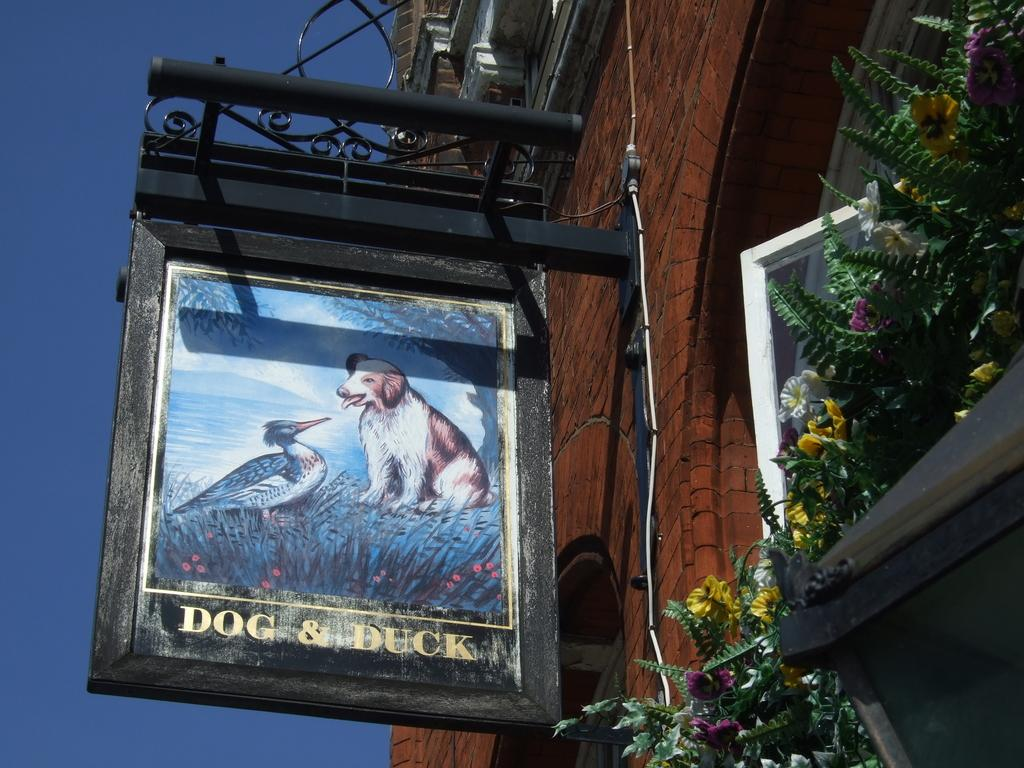What object is attached to the building through metal rods in the image? There is a photo frame in the image that is attached to the building through metal rods. What type of windows does the building have? The building has glass windows. What can be seen on the glass windows? Flowers and plants are present on the glass windows. What else is visible in the image? There are cables visible in the image. What type of worm can be seen crawling on the photo frame in the image? There are no worms present in the image; the photo frame is attached to a building through metal rods. 